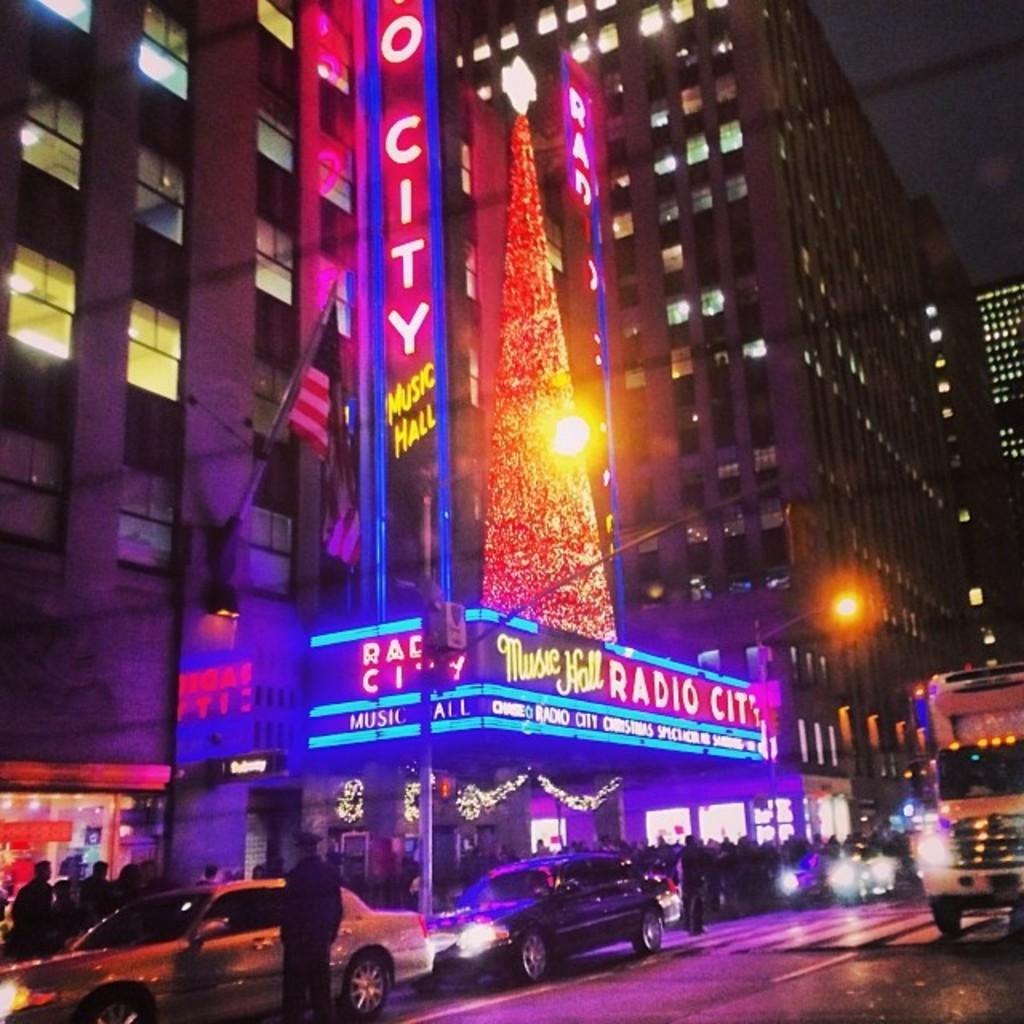Could you give a brief overview of what you see in this image? In this picture we can see buildings, flag, boards, lights, vehicles, and people. 